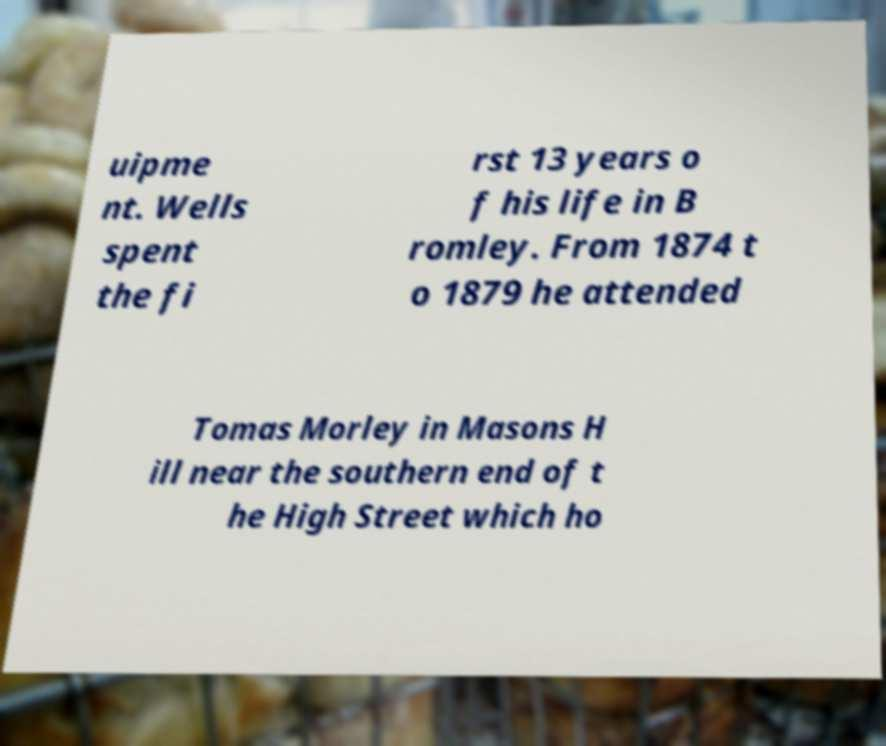Please identify and transcribe the text found in this image. uipme nt. Wells spent the fi rst 13 years o f his life in B romley. From 1874 t o 1879 he attended Tomas Morley in Masons H ill near the southern end of t he High Street which ho 